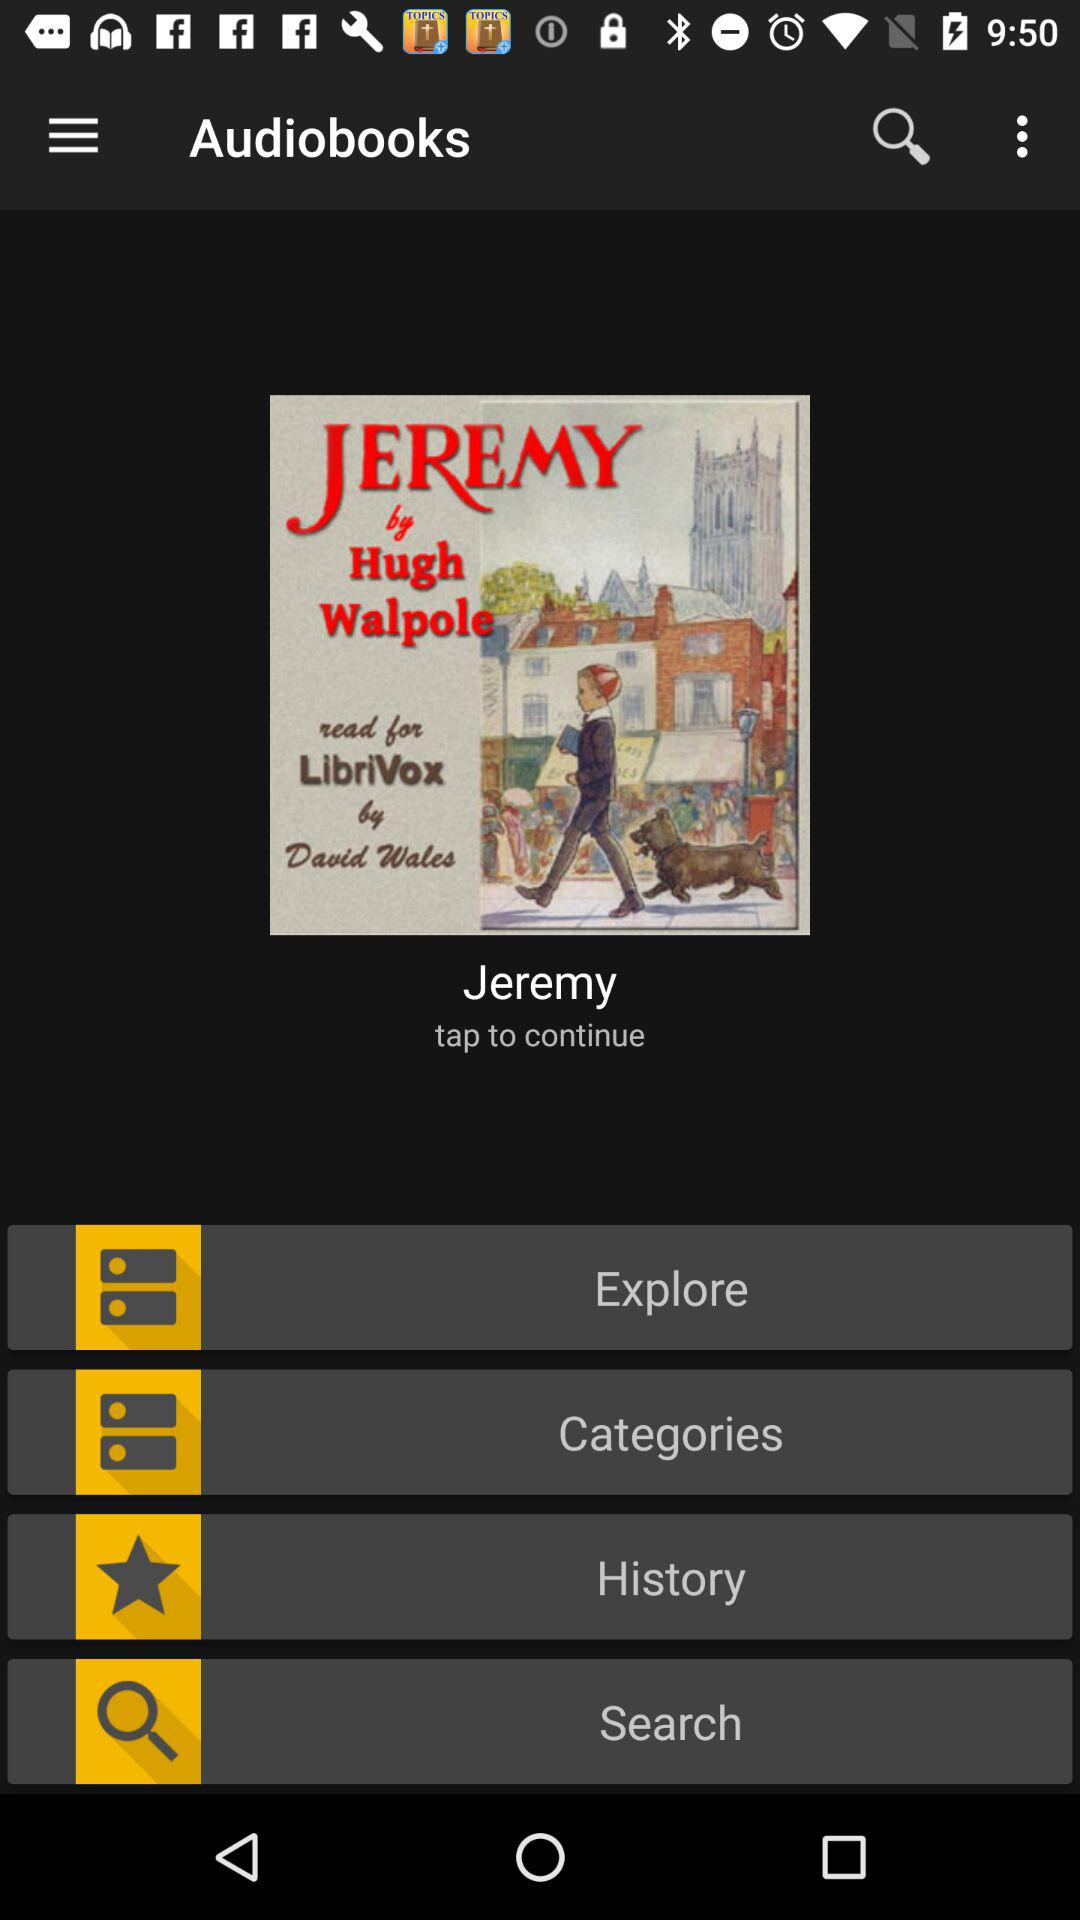What is the duration of the audio book?
When the provided information is insufficient, respond with <no answer>. <no answer> 